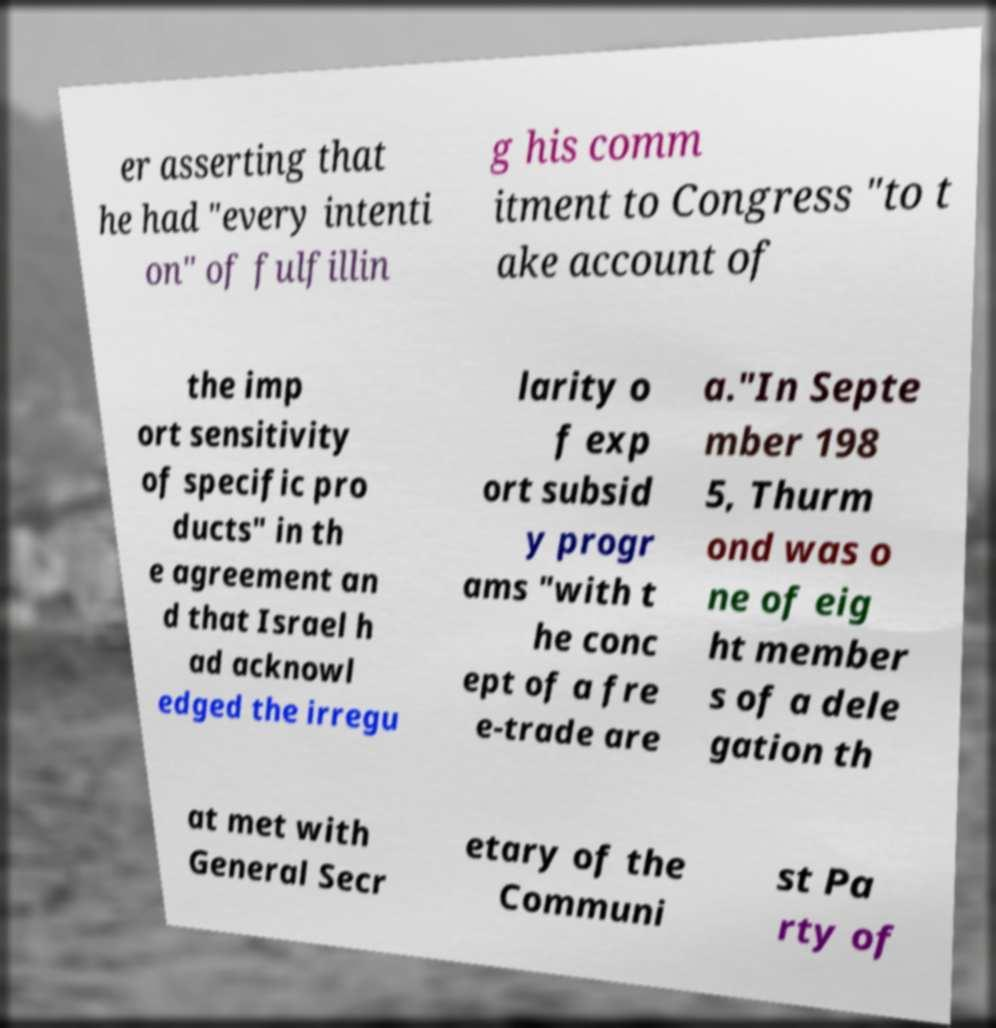Please read and relay the text visible in this image. What does it say? er asserting that he had "every intenti on" of fulfillin g his comm itment to Congress "to t ake account of the imp ort sensitivity of specific pro ducts" in th e agreement an d that Israel h ad acknowl edged the irregu larity o f exp ort subsid y progr ams "with t he conc ept of a fre e-trade are a."In Septe mber 198 5, Thurm ond was o ne of eig ht member s of a dele gation th at met with General Secr etary of the Communi st Pa rty of 